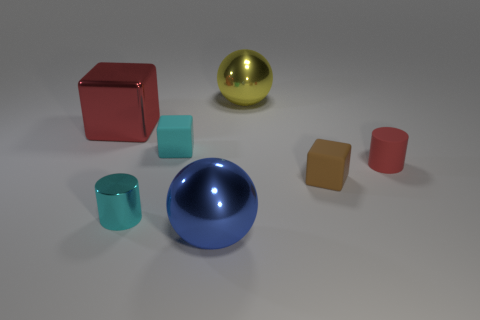There is a cylinder to the left of the small matte block to the left of the big metal thing that is in front of the metal cube; what is it made of?
Offer a very short reply. Metal. There is a small cyan thing that is made of the same material as the large yellow sphere; what is its shape?
Give a very brief answer. Cylinder. Is there a tiny cube to the left of the big metal ball behind the red rubber thing?
Make the answer very short. Yes. The yellow metallic thing is what size?
Provide a short and direct response. Large. How many things are purple shiny balls or big metal cubes?
Provide a succinct answer. 1. Is the material of the ball in front of the brown cube the same as the red object that is to the left of the large blue object?
Provide a short and direct response. Yes. There is a tiny object that is the same material as the large block; what color is it?
Give a very brief answer. Cyan. How many rubber objects have the same size as the matte cylinder?
Your answer should be compact. 2. What number of other things are the same color as the metal cylinder?
Ensure brevity in your answer.  1. There is a large thing on the left side of the cyan rubber cube; does it have the same shape as the tiny cyan object that is right of the metallic cylinder?
Give a very brief answer. Yes. 